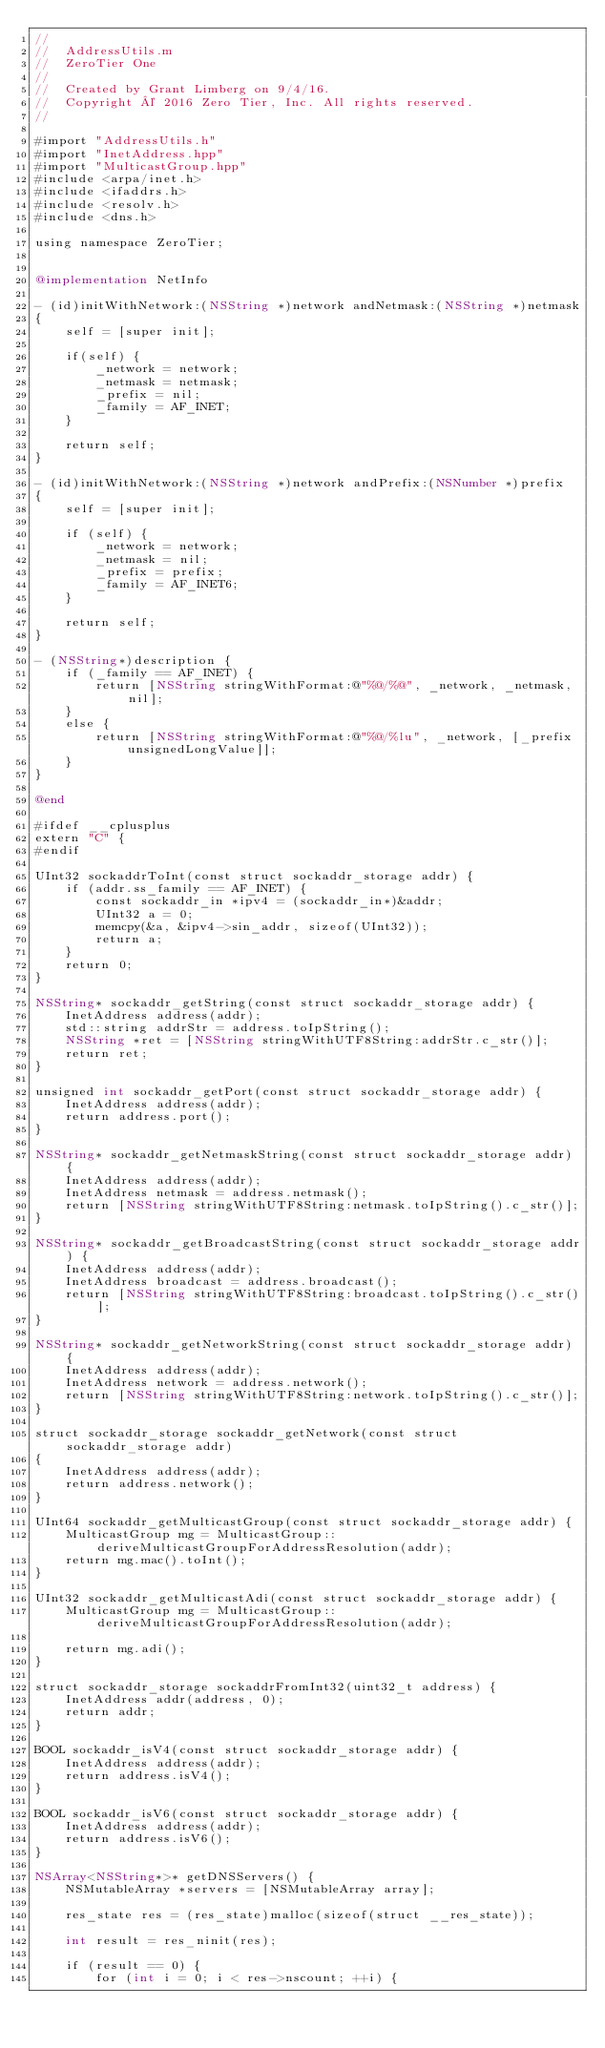Convert code to text. <code><loc_0><loc_0><loc_500><loc_500><_ObjectiveC_>//
//  AddressUtils.m
//  ZeroTier One
//
//  Created by Grant Limberg on 9/4/16.
//  Copyright © 2016 Zero Tier, Inc. All rights reserved.
//

#import "AddressUtils.h"
#import "InetAddress.hpp"
#import "MulticastGroup.hpp"
#include <arpa/inet.h>
#include <ifaddrs.h>
#include <resolv.h>
#include <dns.h>

using namespace ZeroTier;


@implementation NetInfo

- (id)initWithNetwork:(NSString *)network andNetmask:(NSString *)netmask
{
    self = [super init];

    if(self) {
        _network = network;
        _netmask = netmask;
        _prefix = nil;
        _family = AF_INET;
    }

    return self;
}

- (id)initWithNetwork:(NSString *)network andPrefix:(NSNumber *)prefix
{
    self = [super init];

    if (self) {
        _network = network;
        _netmask = nil;
        _prefix = prefix;
        _family = AF_INET6;
    }

    return self;
}

- (NSString*)description {
    if (_family == AF_INET) {
        return [NSString stringWithFormat:@"%@/%@", _network, _netmask, nil];
    }
    else {
        return [NSString stringWithFormat:@"%@/%lu", _network, [_prefix unsignedLongValue]];
    }
}

@end

#ifdef __cplusplus
extern "C" {
#endif

UInt32 sockaddrToInt(const struct sockaddr_storage addr) {
    if (addr.ss_family == AF_INET) {
        const sockaddr_in *ipv4 = (sockaddr_in*)&addr;
        UInt32 a = 0;
        memcpy(&a, &ipv4->sin_addr, sizeof(UInt32));
        return a;
    }
    return 0;
}

NSString* sockaddr_getString(const struct sockaddr_storage addr) {
    InetAddress address(addr);
    std::string addrStr = address.toIpString();
    NSString *ret = [NSString stringWithUTF8String:addrStr.c_str()];
    return ret;
}

unsigned int sockaddr_getPort(const struct sockaddr_storage addr) {
    InetAddress address(addr);
    return address.port();
}

NSString* sockaddr_getNetmaskString(const struct sockaddr_storage addr) {
    InetAddress address(addr);
    InetAddress netmask = address.netmask();
    return [NSString stringWithUTF8String:netmask.toIpString().c_str()];
}

NSString* sockaddr_getBroadcastString(const struct sockaddr_storage addr) {
    InetAddress address(addr);
    InetAddress broadcast = address.broadcast();
    return [NSString stringWithUTF8String:broadcast.toIpString().c_str()];
}

NSString* sockaddr_getNetworkString(const struct sockaddr_storage addr) {
    InetAddress address(addr);
    InetAddress network = address.network();
    return [NSString stringWithUTF8String:network.toIpString().c_str()];
}

struct sockaddr_storage sockaddr_getNetwork(const struct sockaddr_storage addr)
{
    InetAddress address(addr);
    return address.network();
}

UInt64 sockaddr_getMulticastGroup(const struct sockaddr_storage addr) {
    MulticastGroup mg = MulticastGroup::deriveMulticastGroupForAddressResolution(addr);
    return mg.mac().toInt();
}

UInt32 sockaddr_getMulticastAdi(const struct sockaddr_storage addr) {
    MulticastGroup mg = MulticastGroup::deriveMulticastGroupForAddressResolution(addr);

    return mg.adi();
}

struct sockaddr_storage sockaddrFromInt32(uint32_t address) {
    InetAddress addr(address, 0);
    return addr;
}

BOOL sockaddr_isV4(const struct sockaddr_storage addr) {
    InetAddress address(addr);
    return address.isV4();
}

BOOL sockaddr_isV6(const struct sockaddr_storage addr) {
    InetAddress address(addr);
    return address.isV6();
}

NSArray<NSString*>* getDNSServers() {
    NSMutableArray *servers = [NSMutableArray array];

    res_state res = (res_state)malloc(sizeof(struct __res_state));

    int result = res_ninit(res);

    if (result == 0) {
        for (int i = 0; i < res->nscount; ++i) {</code> 